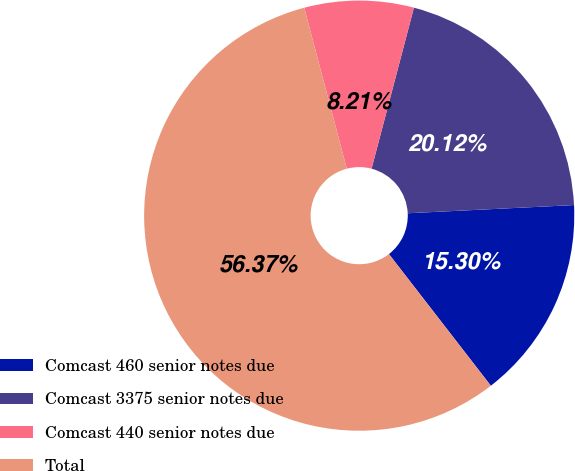Convert chart to OTSL. <chart><loc_0><loc_0><loc_500><loc_500><pie_chart><fcel>Comcast 460 senior notes due<fcel>Comcast 3375 senior notes due<fcel>Comcast 440 senior notes due<fcel>Total<nl><fcel>15.3%<fcel>20.12%<fcel>8.21%<fcel>56.37%<nl></chart> 